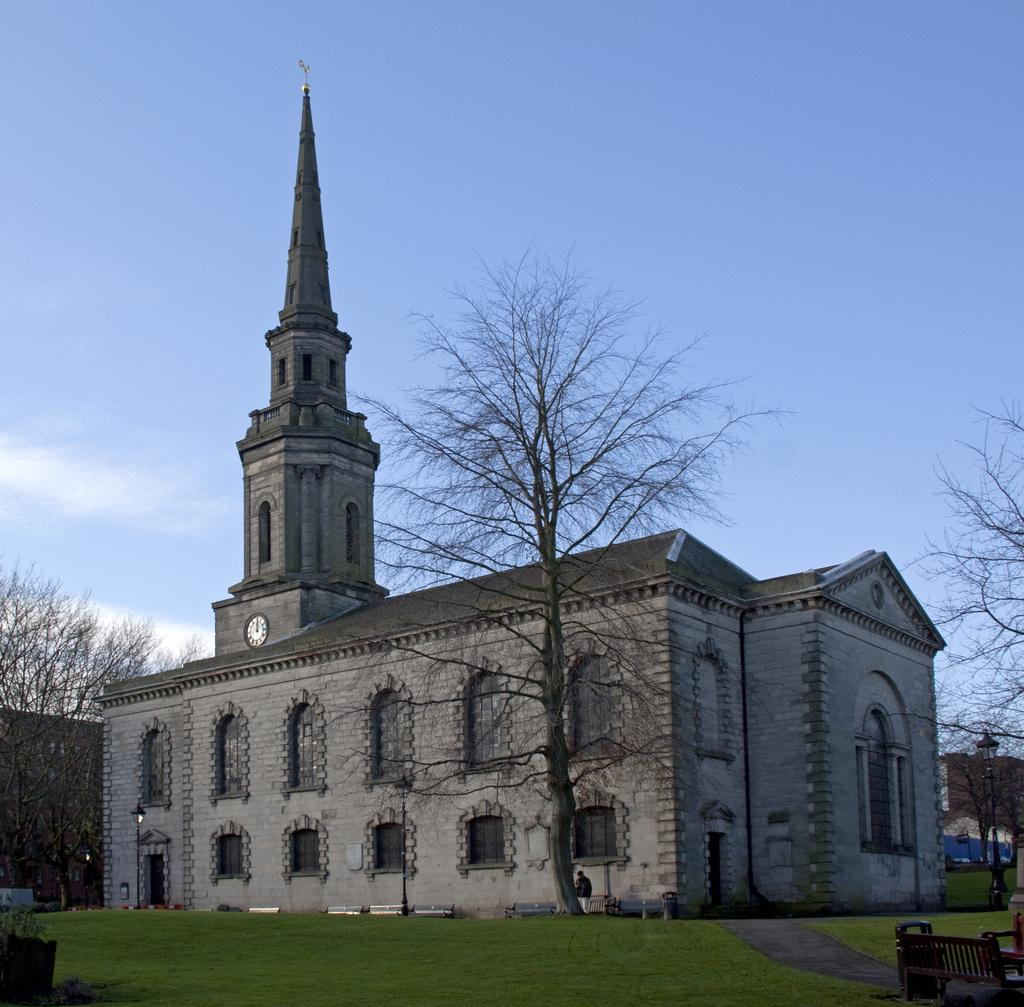What type of vegetation is present in the foreground of the image? There is grass in the foreground of the image. What else can be seen in the foreground of the image? There is a path and chairs in the foreground of the image. What is visible in the background of the image? There is a building, trees, and the sky visible in the background of the image. Where is the secretary sitting in the image? There is no secretary present in the image. What type of mailbox can be seen near the chairs in the image? There is no mailbox visible in the image. 